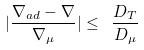Convert formula to latex. <formula><loc_0><loc_0><loc_500><loc_500>| \frac { \nabla _ { a d } - \nabla } { \nabla _ { \mu } } | \leq \ \frac { D _ { T } } { D _ { \mu } }</formula> 